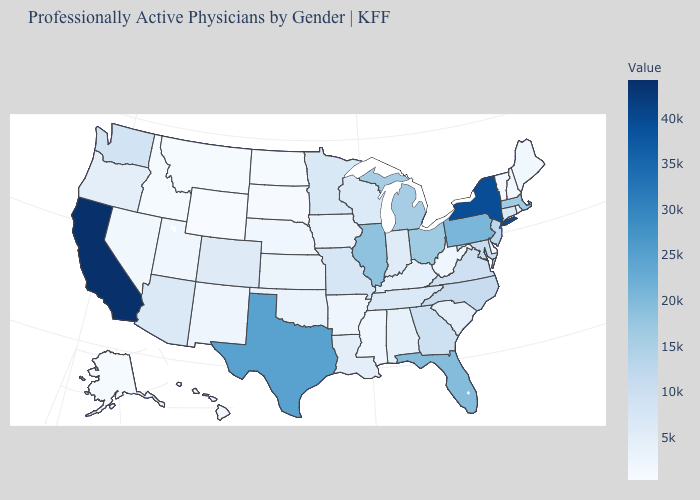Which states hav the highest value in the Northeast?
Be succinct. New York. Is the legend a continuous bar?
Answer briefly. Yes. Which states have the lowest value in the USA?
Quick response, please. Wyoming. Does North Dakota have a higher value than Virginia?
Short answer required. No. 